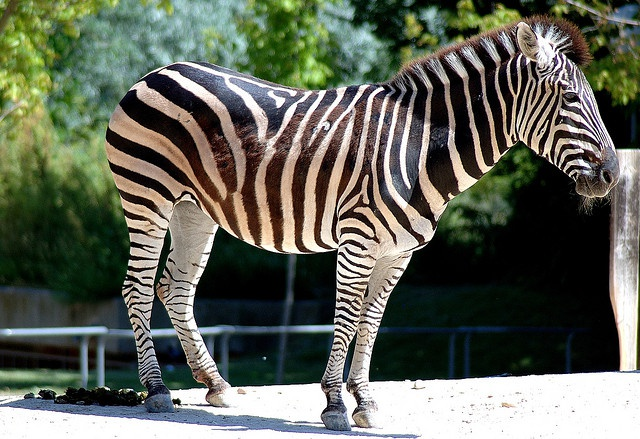Describe the objects in this image and their specific colors. I can see a zebra in lightgreen, black, white, darkgray, and gray tones in this image. 